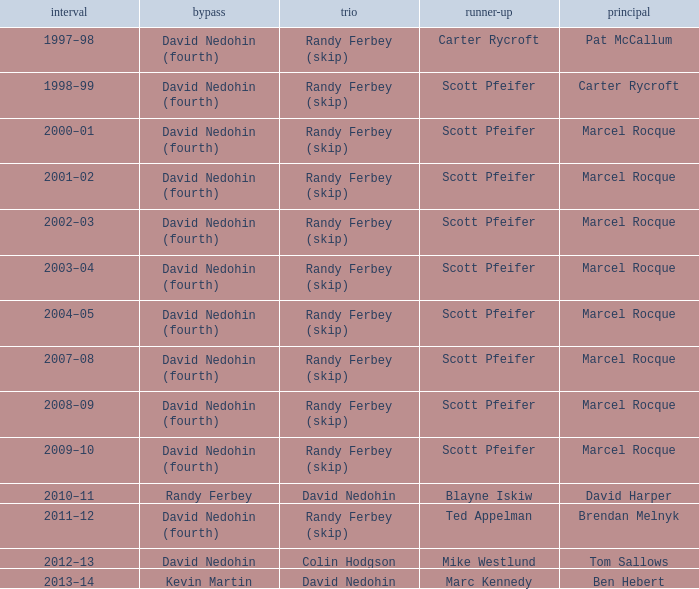Could you parse the entire table as a dict? {'header': ['interval', 'bypass', 'trio', 'runner-up', 'principal'], 'rows': [['1997–98', 'David Nedohin (fourth)', 'Randy Ferbey (skip)', 'Carter Rycroft', 'Pat McCallum'], ['1998–99', 'David Nedohin (fourth)', 'Randy Ferbey (skip)', 'Scott Pfeifer', 'Carter Rycroft'], ['2000–01', 'David Nedohin (fourth)', 'Randy Ferbey (skip)', 'Scott Pfeifer', 'Marcel Rocque'], ['2001–02', 'David Nedohin (fourth)', 'Randy Ferbey (skip)', 'Scott Pfeifer', 'Marcel Rocque'], ['2002–03', 'David Nedohin (fourth)', 'Randy Ferbey (skip)', 'Scott Pfeifer', 'Marcel Rocque'], ['2003–04', 'David Nedohin (fourth)', 'Randy Ferbey (skip)', 'Scott Pfeifer', 'Marcel Rocque'], ['2004–05', 'David Nedohin (fourth)', 'Randy Ferbey (skip)', 'Scott Pfeifer', 'Marcel Rocque'], ['2007–08', 'David Nedohin (fourth)', 'Randy Ferbey (skip)', 'Scott Pfeifer', 'Marcel Rocque'], ['2008–09', 'David Nedohin (fourth)', 'Randy Ferbey (skip)', 'Scott Pfeifer', 'Marcel Rocque'], ['2009–10', 'David Nedohin (fourth)', 'Randy Ferbey (skip)', 'Scott Pfeifer', 'Marcel Rocque'], ['2010–11', 'Randy Ferbey', 'David Nedohin', 'Blayne Iskiw', 'David Harper'], ['2011–12', 'David Nedohin (fourth)', 'Randy Ferbey (skip)', 'Ted Appelman', 'Brendan Melnyk'], ['2012–13', 'David Nedohin', 'Colin Hodgson', 'Mike Westlund', 'Tom Sallows'], ['2013–14', 'Kevin Martin', 'David Nedohin', 'Marc Kennedy', 'Ben Hebert']]} Which Skip has a Season of 2002–03? David Nedohin (fourth). 